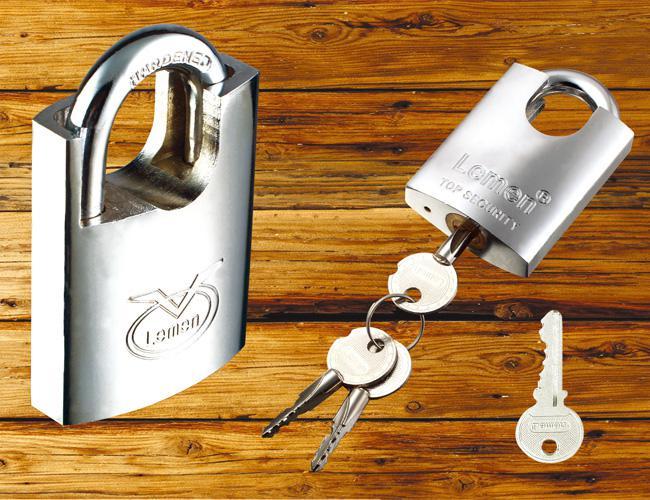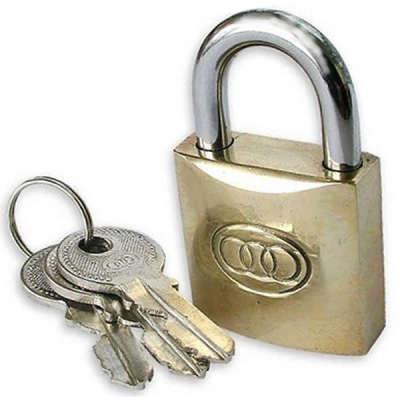The first image is the image on the left, the second image is the image on the right. Given the left and right images, does the statement "There are exactly six keys." hold true? Answer yes or no. No. The first image is the image on the left, the second image is the image on the right. Assess this claim about the two images: "Each image contains exactly three keys and only gold-bodied locks.". Correct or not? Answer yes or no. No. 